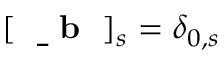Convert formula to latex. <formula><loc_0><loc_0><loc_500><loc_500>[ { b } ] _ { s } = \delta _ { 0 , s }</formula> 